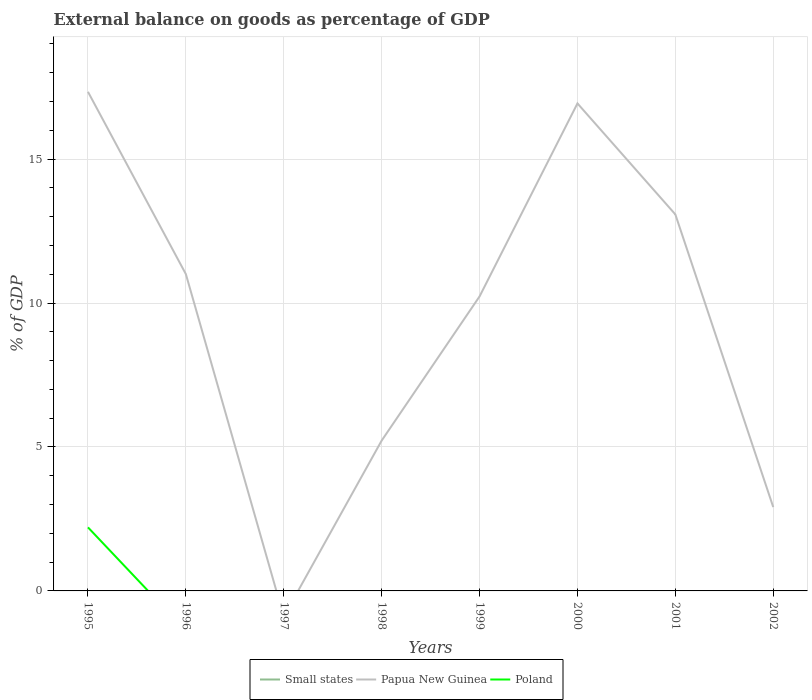Does the line corresponding to Small states intersect with the line corresponding to Poland?
Give a very brief answer. Yes. Is the number of lines equal to the number of legend labels?
Ensure brevity in your answer.  No. What is the total external balance on goods as percentage of GDP in Papua New Guinea in the graph?
Provide a succinct answer. 4.26. What is the difference between the highest and the second highest external balance on goods as percentage of GDP in Poland?
Your answer should be very brief. 2.21. What is the difference between the highest and the lowest external balance on goods as percentage of GDP in Papua New Guinea?
Provide a succinct answer. 5. Is the external balance on goods as percentage of GDP in Poland strictly greater than the external balance on goods as percentage of GDP in Papua New Guinea over the years?
Offer a terse response. Yes. How many lines are there?
Give a very brief answer. 2. How many years are there in the graph?
Keep it short and to the point. 8. What is the difference between two consecutive major ticks on the Y-axis?
Keep it short and to the point. 5. Are the values on the major ticks of Y-axis written in scientific E-notation?
Ensure brevity in your answer.  No. How many legend labels are there?
Your response must be concise. 3. What is the title of the graph?
Offer a very short reply. External balance on goods as percentage of GDP. Does "Switzerland" appear as one of the legend labels in the graph?
Your response must be concise. No. What is the label or title of the Y-axis?
Make the answer very short. % of GDP. What is the % of GDP in Papua New Guinea in 1995?
Your answer should be compact. 17.34. What is the % of GDP of Poland in 1995?
Keep it short and to the point. 2.21. What is the % of GDP of Small states in 1996?
Give a very brief answer. 0. What is the % of GDP in Papua New Guinea in 1996?
Give a very brief answer. 11.01. What is the % of GDP in Poland in 1997?
Keep it short and to the point. 0. What is the % of GDP of Papua New Guinea in 1998?
Offer a very short reply. 5.22. What is the % of GDP of Poland in 1998?
Offer a terse response. 0. What is the % of GDP in Small states in 1999?
Keep it short and to the point. 0. What is the % of GDP of Papua New Guinea in 1999?
Provide a succinct answer. 10.23. What is the % of GDP in Papua New Guinea in 2000?
Provide a succinct answer. 16.93. What is the % of GDP of Small states in 2001?
Your response must be concise. 0. What is the % of GDP in Papua New Guinea in 2001?
Your answer should be very brief. 13.08. What is the % of GDP of Small states in 2002?
Your answer should be compact. 0. What is the % of GDP of Papua New Guinea in 2002?
Offer a very short reply. 2.91. Across all years, what is the maximum % of GDP in Papua New Guinea?
Ensure brevity in your answer.  17.34. Across all years, what is the maximum % of GDP of Poland?
Provide a short and direct response. 2.21. Across all years, what is the minimum % of GDP in Papua New Guinea?
Provide a short and direct response. 0. Across all years, what is the minimum % of GDP in Poland?
Your response must be concise. 0. What is the total % of GDP in Papua New Guinea in the graph?
Provide a succinct answer. 76.72. What is the total % of GDP in Poland in the graph?
Your answer should be compact. 2.21. What is the difference between the % of GDP in Papua New Guinea in 1995 and that in 1996?
Make the answer very short. 6.33. What is the difference between the % of GDP of Papua New Guinea in 1995 and that in 1998?
Give a very brief answer. 12.12. What is the difference between the % of GDP in Papua New Guinea in 1995 and that in 1999?
Ensure brevity in your answer.  7.11. What is the difference between the % of GDP of Papua New Guinea in 1995 and that in 2000?
Give a very brief answer. 0.4. What is the difference between the % of GDP of Papua New Guinea in 1995 and that in 2001?
Provide a short and direct response. 4.26. What is the difference between the % of GDP of Papua New Guinea in 1995 and that in 2002?
Provide a short and direct response. 14.43. What is the difference between the % of GDP in Papua New Guinea in 1996 and that in 1998?
Your answer should be very brief. 5.78. What is the difference between the % of GDP in Papua New Guinea in 1996 and that in 1999?
Provide a short and direct response. 0.78. What is the difference between the % of GDP of Papua New Guinea in 1996 and that in 2000?
Offer a very short reply. -5.93. What is the difference between the % of GDP of Papua New Guinea in 1996 and that in 2001?
Ensure brevity in your answer.  -2.07. What is the difference between the % of GDP of Papua New Guinea in 1996 and that in 2002?
Ensure brevity in your answer.  8.09. What is the difference between the % of GDP of Papua New Guinea in 1998 and that in 1999?
Ensure brevity in your answer.  -5.01. What is the difference between the % of GDP in Papua New Guinea in 1998 and that in 2000?
Ensure brevity in your answer.  -11.71. What is the difference between the % of GDP of Papua New Guinea in 1998 and that in 2001?
Your answer should be compact. -7.86. What is the difference between the % of GDP in Papua New Guinea in 1998 and that in 2002?
Your answer should be very brief. 2.31. What is the difference between the % of GDP of Papua New Guinea in 1999 and that in 2000?
Offer a terse response. -6.71. What is the difference between the % of GDP in Papua New Guinea in 1999 and that in 2001?
Give a very brief answer. -2.85. What is the difference between the % of GDP in Papua New Guinea in 1999 and that in 2002?
Provide a short and direct response. 7.32. What is the difference between the % of GDP of Papua New Guinea in 2000 and that in 2001?
Give a very brief answer. 3.86. What is the difference between the % of GDP of Papua New Guinea in 2000 and that in 2002?
Your answer should be compact. 14.02. What is the difference between the % of GDP in Papua New Guinea in 2001 and that in 2002?
Make the answer very short. 10.17. What is the average % of GDP in Papua New Guinea per year?
Provide a succinct answer. 9.59. What is the average % of GDP in Poland per year?
Provide a succinct answer. 0.28. In the year 1995, what is the difference between the % of GDP of Papua New Guinea and % of GDP of Poland?
Ensure brevity in your answer.  15.13. What is the ratio of the % of GDP of Papua New Guinea in 1995 to that in 1996?
Provide a short and direct response. 1.58. What is the ratio of the % of GDP in Papua New Guinea in 1995 to that in 1998?
Provide a succinct answer. 3.32. What is the ratio of the % of GDP in Papua New Guinea in 1995 to that in 1999?
Offer a very short reply. 1.69. What is the ratio of the % of GDP in Papua New Guinea in 1995 to that in 2000?
Provide a succinct answer. 1.02. What is the ratio of the % of GDP in Papua New Guinea in 1995 to that in 2001?
Your answer should be very brief. 1.33. What is the ratio of the % of GDP in Papua New Guinea in 1995 to that in 2002?
Make the answer very short. 5.95. What is the ratio of the % of GDP of Papua New Guinea in 1996 to that in 1998?
Offer a terse response. 2.11. What is the ratio of the % of GDP in Papua New Guinea in 1996 to that in 1999?
Keep it short and to the point. 1.08. What is the ratio of the % of GDP in Papua New Guinea in 1996 to that in 2000?
Offer a very short reply. 0.65. What is the ratio of the % of GDP of Papua New Guinea in 1996 to that in 2001?
Provide a short and direct response. 0.84. What is the ratio of the % of GDP in Papua New Guinea in 1996 to that in 2002?
Your response must be concise. 3.78. What is the ratio of the % of GDP of Papua New Guinea in 1998 to that in 1999?
Keep it short and to the point. 0.51. What is the ratio of the % of GDP in Papua New Guinea in 1998 to that in 2000?
Your answer should be very brief. 0.31. What is the ratio of the % of GDP in Papua New Guinea in 1998 to that in 2001?
Provide a succinct answer. 0.4. What is the ratio of the % of GDP of Papua New Guinea in 1998 to that in 2002?
Your response must be concise. 1.79. What is the ratio of the % of GDP in Papua New Guinea in 1999 to that in 2000?
Give a very brief answer. 0.6. What is the ratio of the % of GDP in Papua New Guinea in 1999 to that in 2001?
Offer a very short reply. 0.78. What is the ratio of the % of GDP of Papua New Guinea in 1999 to that in 2002?
Offer a terse response. 3.51. What is the ratio of the % of GDP in Papua New Guinea in 2000 to that in 2001?
Your response must be concise. 1.29. What is the ratio of the % of GDP of Papua New Guinea in 2000 to that in 2002?
Your response must be concise. 5.81. What is the ratio of the % of GDP in Papua New Guinea in 2001 to that in 2002?
Make the answer very short. 4.49. What is the difference between the highest and the second highest % of GDP in Papua New Guinea?
Give a very brief answer. 0.4. What is the difference between the highest and the lowest % of GDP in Papua New Guinea?
Provide a succinct answer. 17.34. What is the difference between the highest and the lowest % of GDP in Poland?
Make the answer very short. 2.21. 